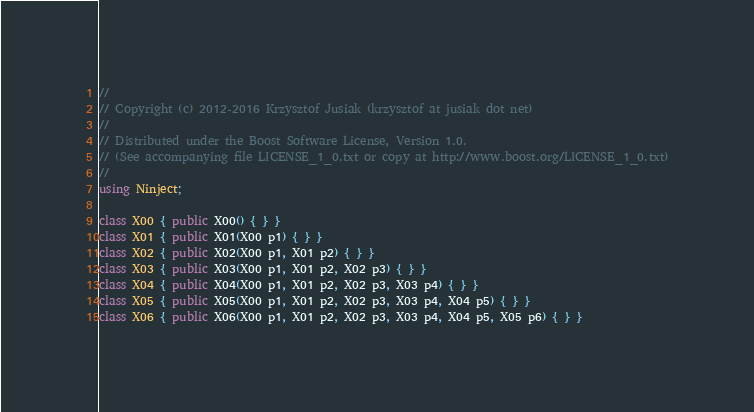Convert code to text. <code><loc_0><loc_0><loc_500><loc_500><_C#_>//
// Copyright (c) 2012-2016 Krzysztof Jusiak (krzysztof at jusiak dot net)
//
// Distributed under the Boost Software License, Version 1.0.
// (See accompanying file LICENSE_1_0.txt or copy at http://www.boost.org/LICENSE_1_0.txt)
//
using Ninject;

class X00 { public X00() { } }
class X01 { public X01(X00 p1) { } }
class X02 { public X02(X00 p1, X01 p2) { } }
class X03 { public X03(X00 p1, X01 p2, X02 p3) { } }
class X04 { public X04(X00 p1, X01 p2, X02 p3, X03 p4) { } }
class X05 { public X05(X00 p1, X01 p2, X02 p3, X03 p4, X04 p5) { } }
class X06 { public X06(X00 p1, X01 p2, X02 p3, X03 p4, X04 p5, X05 p6) { } }</code> 